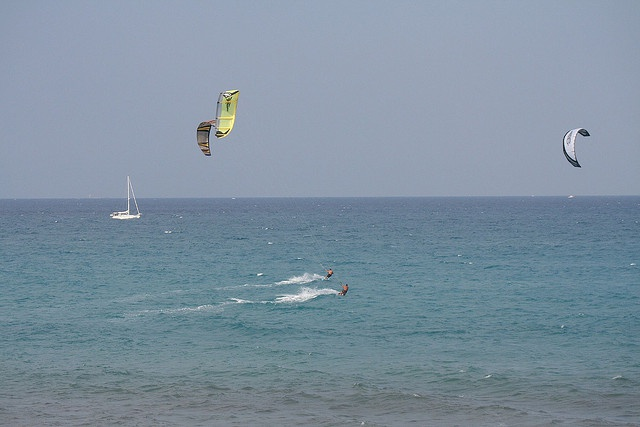Describe the objects in this image and their specific colors. I can see kite in darkgray, khaki, and tan tones, boat in darkgray, lightgray, and gray tones, kite in darkgray, lavender, and gray tones, people in darkgray, gray, salmon, and black tones, and people in darkgray, gray, black, and salmon tones in this image. 